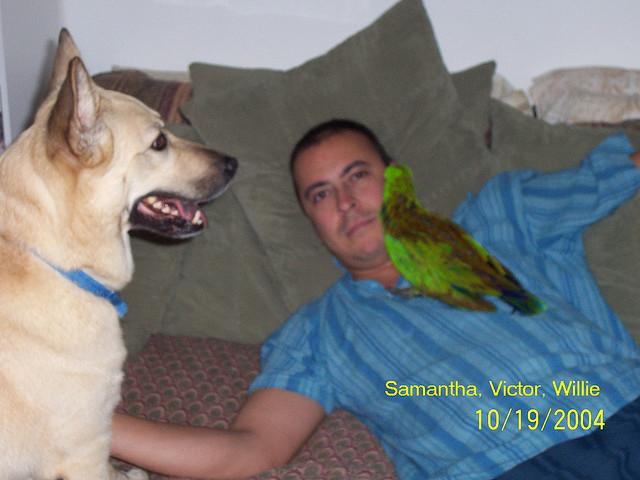What breed are these dogs?
Keep it brief. German shepherd. What kind of bird is in the picture?
Concise answer only. Parrot. What type of dog is this?
Write a very short answer. Lab. What color are the dogs' eyes?
Keep it brief. Brown. How many animals are there?
Write a very short answer. 2. What color is the dog's leash?
Keep it brief. Blue. Did the dog catch the frisbee?
Be succinct. No. Is the bird afraid of the dog?
Answer briefly. No. Is the dog tied to a chain?
Be succinct. No. Are these animals hatched from eggs?
Write a very short answer. Yes. Is the dog begging for food scraps?
Answer briefly. No. When was this picture taken?
Quick response, please. 10/19/2004. What date was this picture taken?
Answer briefly. 10/19/2004. What breed of dog is shown?
Answer briefly. German shepherd. What is the dog wearing?
Keep it brief. Collar. Are both dog's ears erect?
Keep it brief. Yes. What kind of dogs that are in the picture?
Short answer required. German shepherd. What breed of dog is this?
Give a very brief answer. Shepherd. What kind of dog is in the picture?
Be succinct. German shepherd. What color is the dog's collar?
Quick response, please. Blue. What type of animal is in the picture?
Quick response, please. Dog. What is the dog doing?
Short answer required. Sitting. Is the dog jumping?
Write a very short answer. No. What is the dog sitting on?
Keep it brief. Couch. What color is the dog?
Write a very short answer. Brown. 